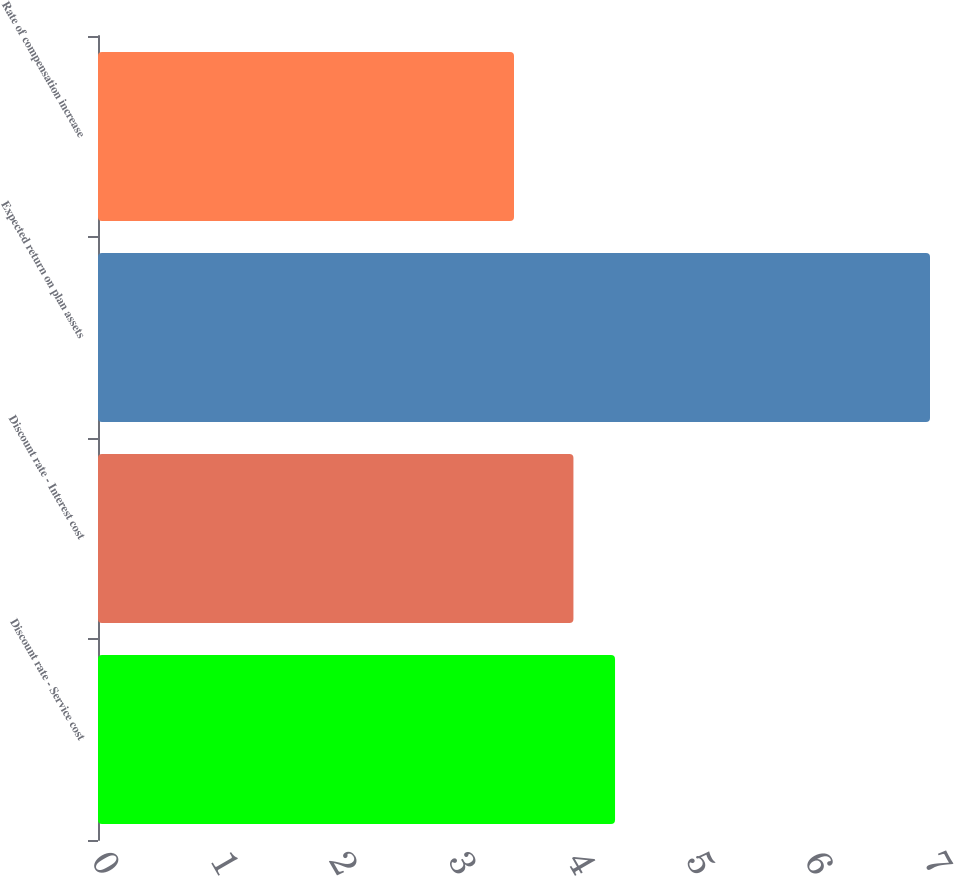Convert chart. <chart><loc_0><loc_0><loc_500><loc_500><bar_chart><fcel>Discount rate - Service cost<fcel>Discount rate - Interest cost<fcel>Expected return on plan assets<fcel>Rate of compensation increase<nl><fcel>4.35<fcel>4<fcel>7<fcel>3.5<nl></chart> 